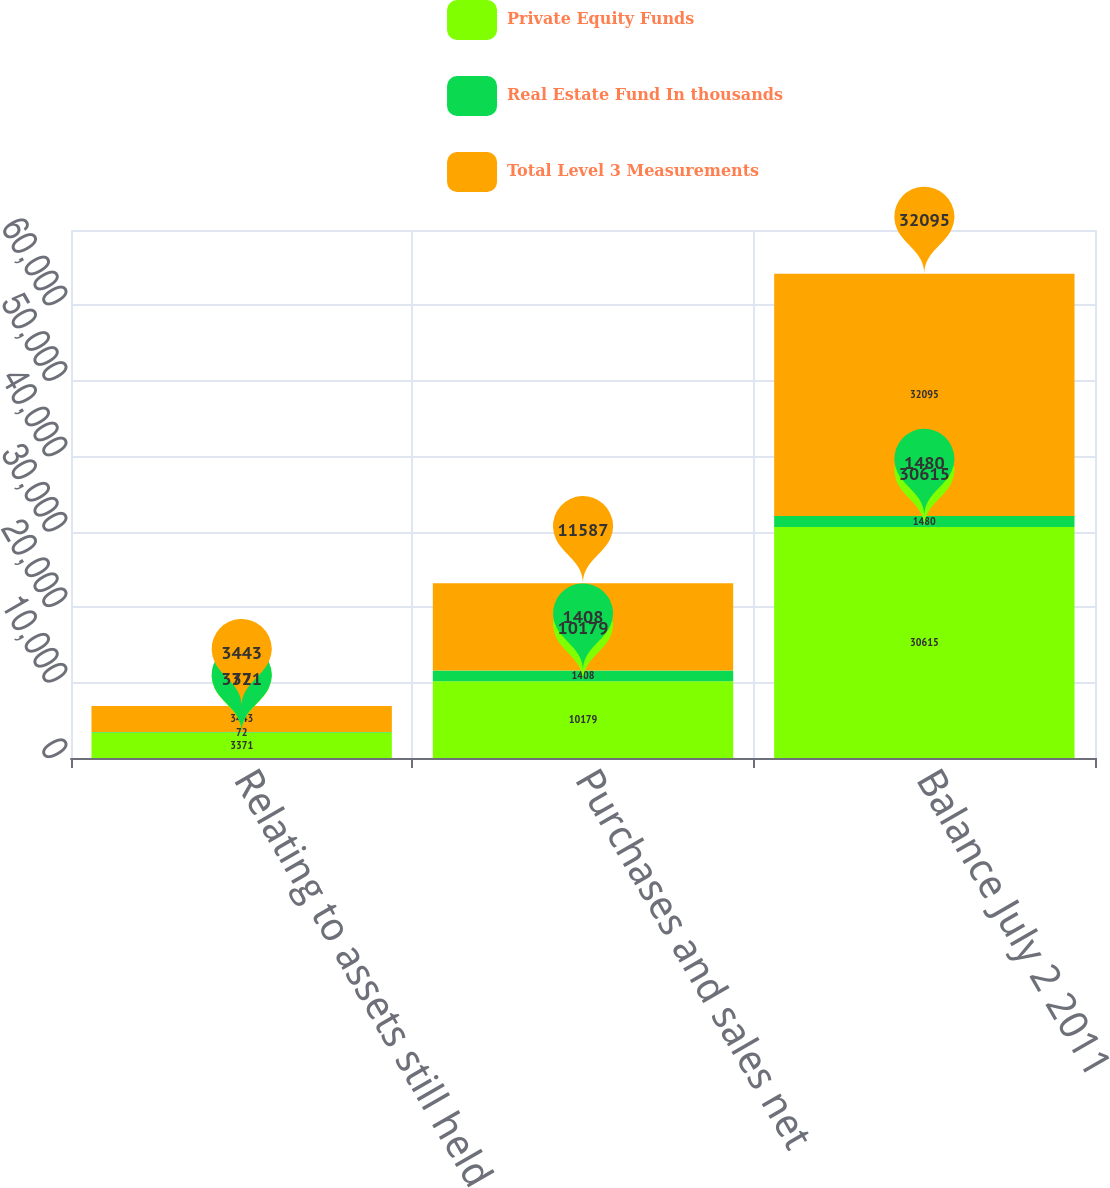<chart> <loc_0><loc_0><loc_500><loc_500><stacked_bar_chart><ecel><fcel>Relating to assets still held<fcel>Purchases and sales net<fcel>Balance July 2 2011<nl><fcel>Private Equity Funds<fcel>3371<fcel>10179<fcel>30615<nl><fcel>Real Estate Fund In thousands<fcel>72<fcel>1408<fcel>1480<nl><fcel>Total Level 3 Measurements<fcel>3443<fcel>11587<fcel>32095<nl></chart> 